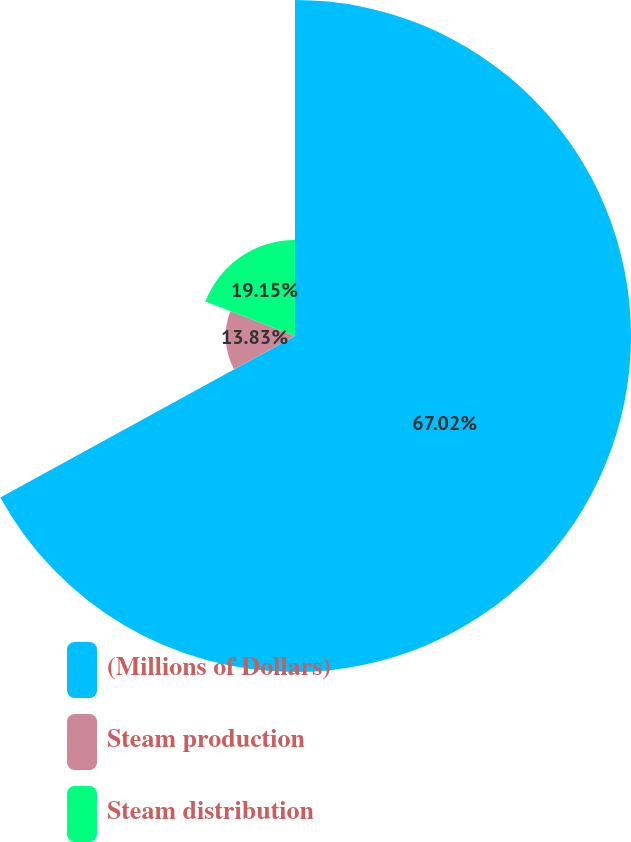Convert chart to OTSL. <chart><loc_0><loc_0><loc_500><loc_500><pie_chart><fcel>(Millions of Dollars)<fcel>Steam production<fcel>Steam distribution<nl><fcel>67.02%<fcel>13.83%<fcel>19.15%<nl></chart> 